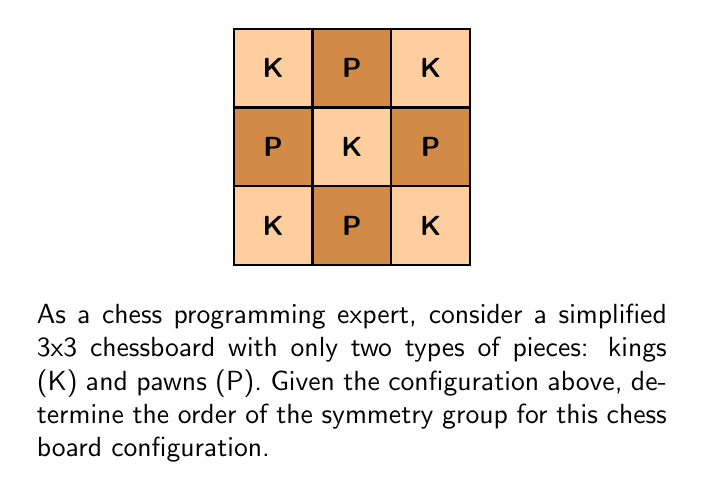Could you help me with this problem? To solve this problem, we need to follow these steps:

1) First, let's identify the symmetries of this configuration:

   a) Rotational symmetry: The board can be rotated by 180° and maintain the same configuration.
   b) Reflection symmetry: The board can be reflected across its horizontal middle line.

2) These symmetries form a group. Let's call the identity transformation $e$, the 180° rotation $r$, and the reflection $f$.

3) We can represent the group operations in a Cayley table:

   $$\begin{array}{c|ccc}
     & e & r & f \\
   \hline
   e & e & r & f \\
   r & r & e & f \\
   f & f & f & e
   \end{array}$$

4) From this table, we can verify that these operations satisfy the group axioms:
   - Closure: The result of any two operations is in the set {e, r, f}
   - Associativity: This is inherent in geometric transformations
   - Identity: e is the identity element
   - Inverse: Each element is its own inverse

5) The order of a group is the number of elements in the group. In this case, we have 3 elements: {e, r, f}.

Therefore, the order of the symmetry group for this chess board configuration is 3.
Answer: 3 